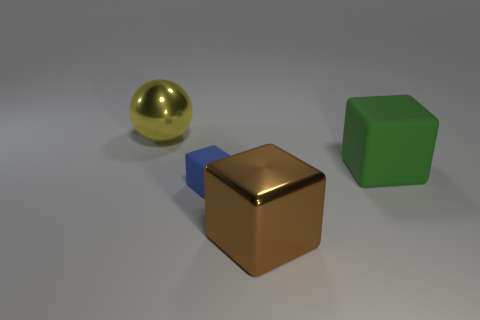What material is the large object that is on the left side of the large metallic thing in front of the blue cube made of? metal 